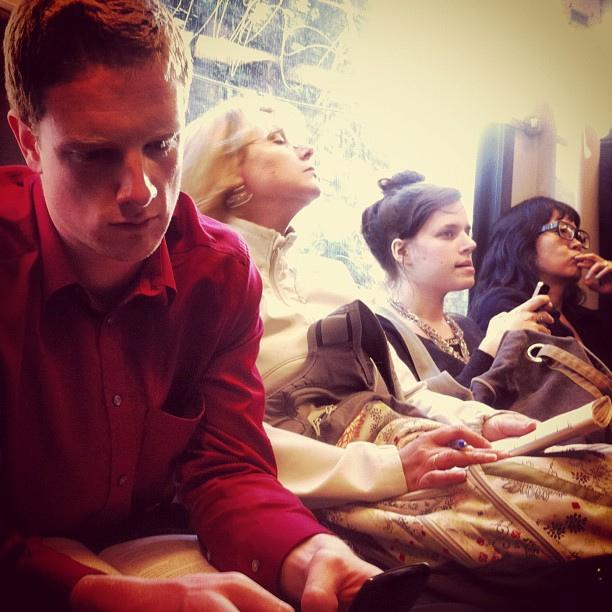The expression on the people's faces reveal that the bus is what? Please explain your reasoning. unpleasant. The expressions show boredom. 